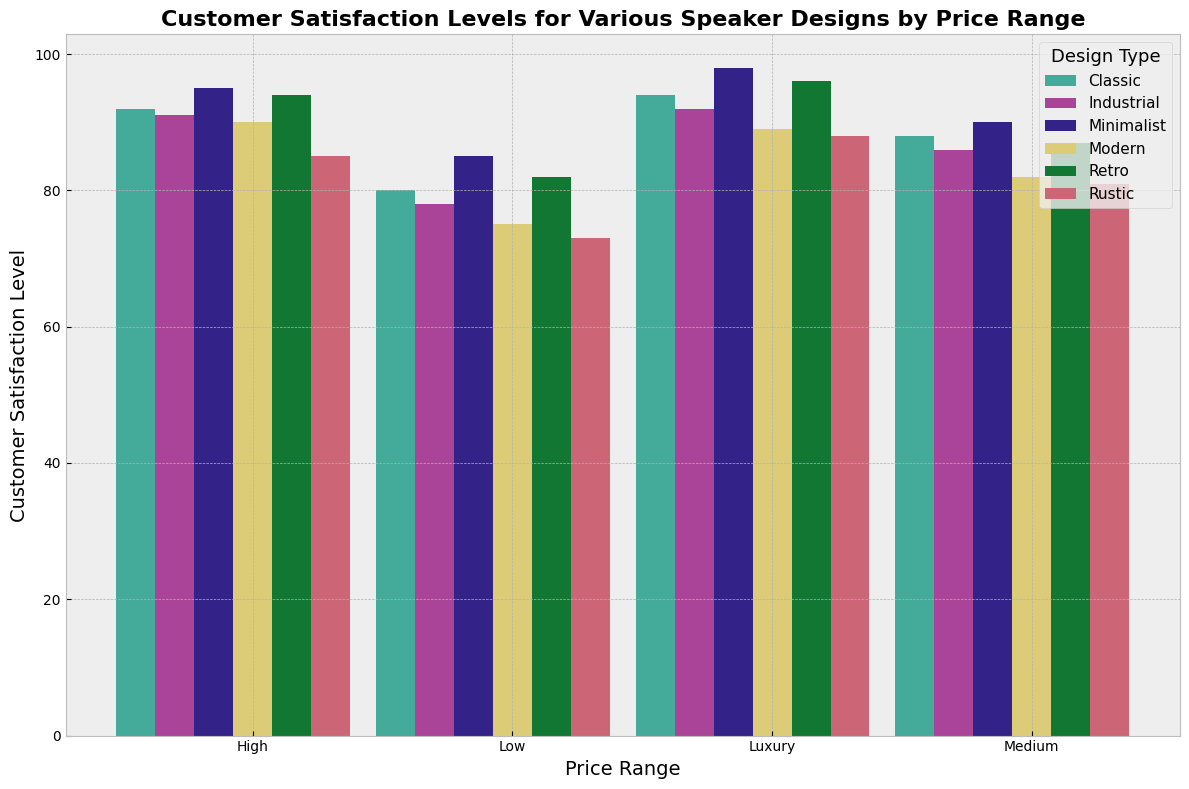Which price range has the highest customer satisfaction level for the Minimalist design? First, observe the bars corresponding to the Minimalist design for each price range. The Luxury price range has the highest bar for the Minimalist design.
Answer: Luxury How much higher is the customer satisfaction level for the Rustic design in the Medium price range compared to the Low price range? Look at the bars for the Rustic design in the Medium and Low price ranges. The satisfaction levels are 81 and 73, respectively. The difference is 81 - 73.
Answer: 8 Which design type consistently shows the highest customer satisfaction across all price ranges? Check all the bars for each design type across all price ranges. The Minimalist design has the highest bars in each price range.
Answer: Minimalist What is the average customer satisfaction level for the Industrial design? Check the satisfaction levels for the Industrial design across all price ranges: 78 (Low), 86 (Medium), 91 (High), and 92 (Luxury). Sum these values and divide by the number of ranges: (78 + 86 + 91 + 92) / 4.
Answer: 86.75 Compare the customer satisfaction levels between the Modern and Classic designs in the High price range. Which is higher? Look at the bars for the High price range for both Modern and Classic designs. The satisfaction levels are 90 for Modern and 92 for Classic.
Answer: Classic How does the satisfaction level of the Retro design in the Luxury price range compare to that of the Modern design in the same range? Check the Luxury price range bars for both Retro and Modern designs. The satisfaction levels are 96 for Retro and 89 for Modern. Calculate the difference: 96 - 89.
Answer: 7 Which design type has the lowest customer satisfaction level in the Low price range? Observe the bars for the Low price range and identify the smallest bar height, which corresponds to the Rustic design with a satisfaction level of 73.
Answer: Rustic What is the difference between the highest and lowest customer satisfaction levels in the Luxury price range? Identify the highest and lowest bars in the Luxury price range: Minimalist at 98 and Rustic at 88. Calculate the difference: 98 - 88.
Answer: 10 